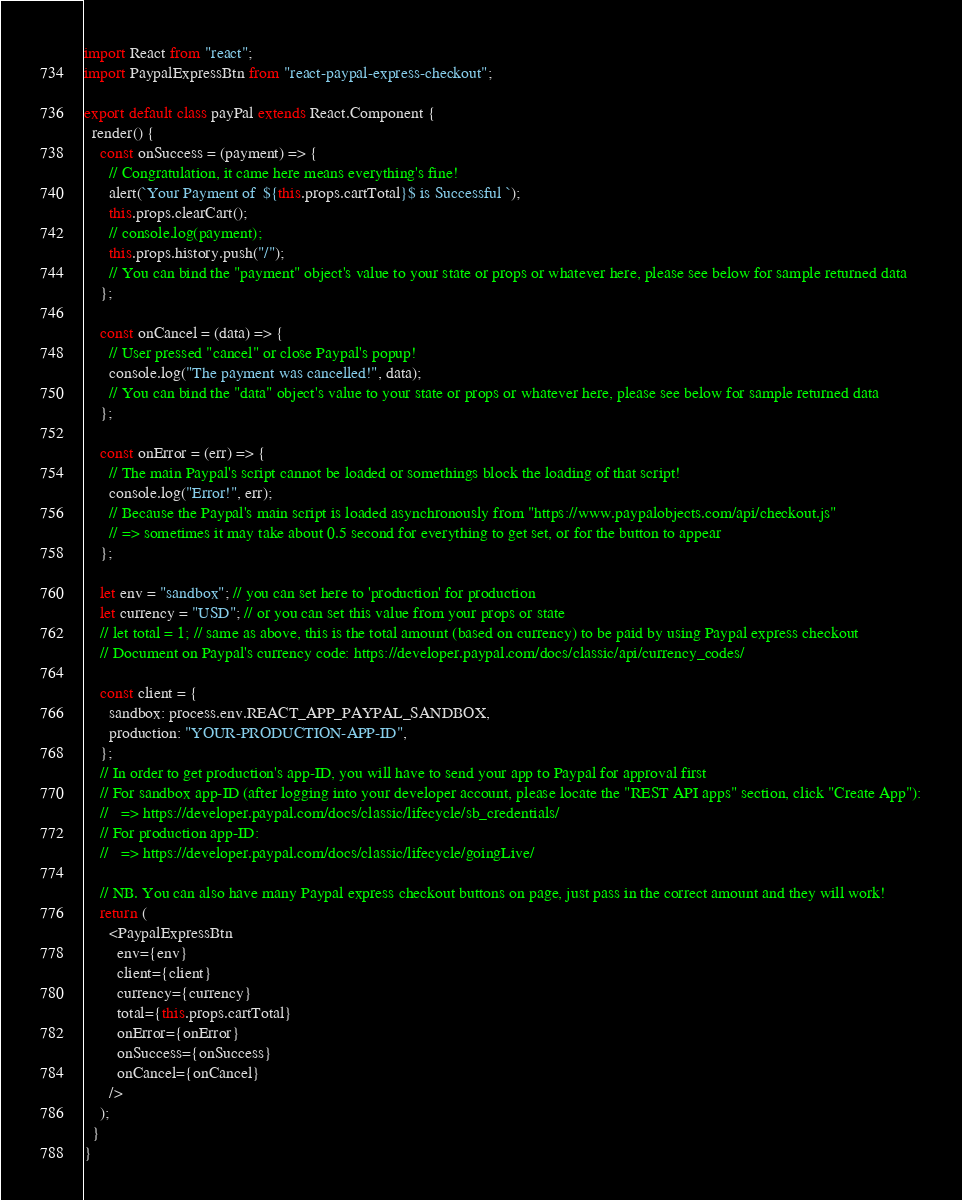<code> <loc_0><loc_0><loc_500><loc_500><_JavaScript_>import React from "react";
import PaypalExpressBtn from "react-paypal-express-checkout";

export default class payPal extends React.Component {
  render() {
    const onSuccess = (payment) => {
      // Congratulation, it came here means everything's fine!
      alert(`Your Payment of  ${this.props.cartTotal}$ is Successful `);
      this.props.clearCart();
      // console.log(payment);
      this.props.history.push("/");
      // You can bind the "payment" object's value to your state or props or whatever here, please see below for sample returned data
    };

    const onCancel = (data) => {
      // User pressed "cancel" or close Paypal's popup!
      console.log("The payment was cancelled!", data);
      // You can bind the "data" object's value to your state or props or whatever here, please see below for sample returned data
    };

    const onError = (err) => {
      // The main Paypal's script cannot be loaded or somethings block the loading of that script!
      console.log("Error!", err);
      // Because the Paypal's main script is loaded asynchronously from "https://www.paypalobjects.com/api/checkout.js"
      // => sometimes it may take about 0.5 second for everything to get set, or for the button to appear
    };

    let env = "sandbox"; // you can set here to 'production' for production
    let currency = "USD"; // or you can set this value from your props or state
    // let total = 1; // same as above, this is the total amount (based on currency) to be paid by using Paypal express checkout
    // Document on Paypal's currency code: https://developer.paypal.com/docs/classic/api/currency_codes/

    const client = {
      sandbox: process.env.REACT_APP_PAYPAL_SANDBOX,
      production: "YOUR-PRODUCTION-APP-ID",
    };
    // In order to get production's app-ID, you will have to send your app to Paypal for approval first
    // For sandbox app-ID (after logging into your developer account, please locate the "REST API apps" section, click "Create App"):
    //   => https://developer.paypal.com/docs/classic/lifecycle/sb_credentials/
    // For production app-ID:
    //   => https://developer.paypal.com/docs/classic/lifecycle/goingLive/

    // NB. You can also have many Paypal express checkout buttons on page, just pass in the correct amount and they will work!
    return (
      <PaypalExpressBtn
        env={env}
        client={client}
        currency={currency}
        total={this.props.cartTotal}
        onError={onError}
        onSuccess={onSuccess}
        onCancel={onCancel}
      />
    );
  }
}
</code> 